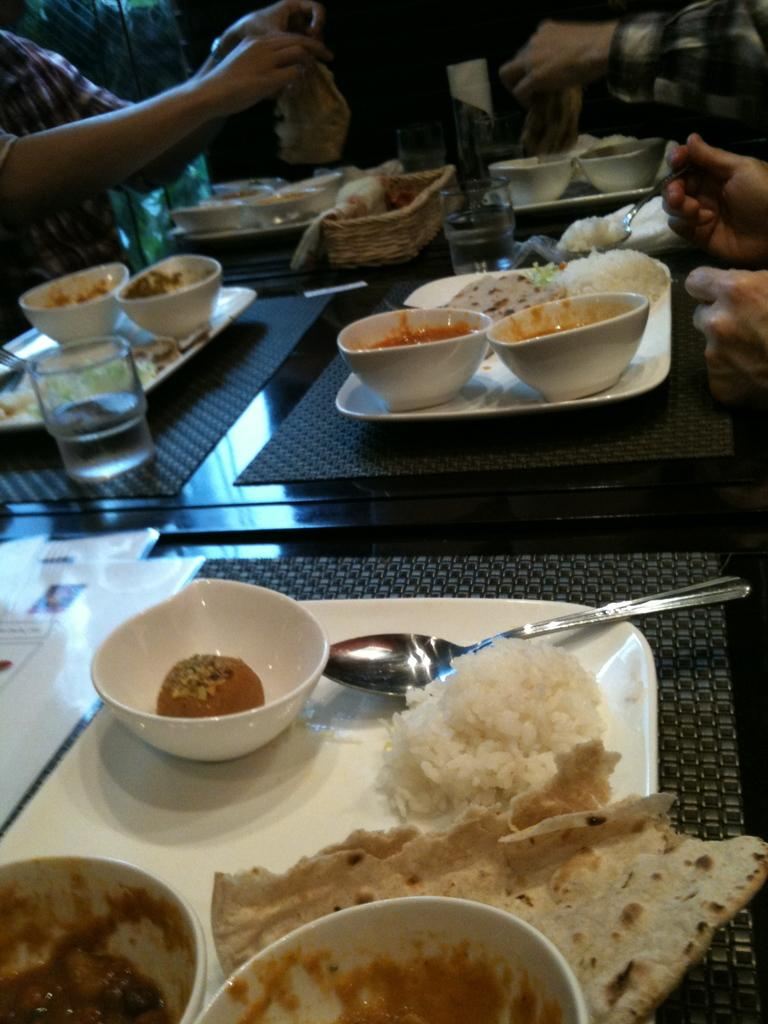What type of objects can be seen in the image? There are food items in the image. Are there any people present in the image? Yes, there are persons in the image. What are the persons doing with the food items? The persons are holding food in their hands. Can you describe the utensil being used by one of the persons? There is a person holding a spoon in the image. What type of bean is being used in the operation depicted in the image? There is no operation or bean present in the image; it features persons holding food items and a person holding a spoon. Is there any poison visible in the image? There is no poison present in the image. 